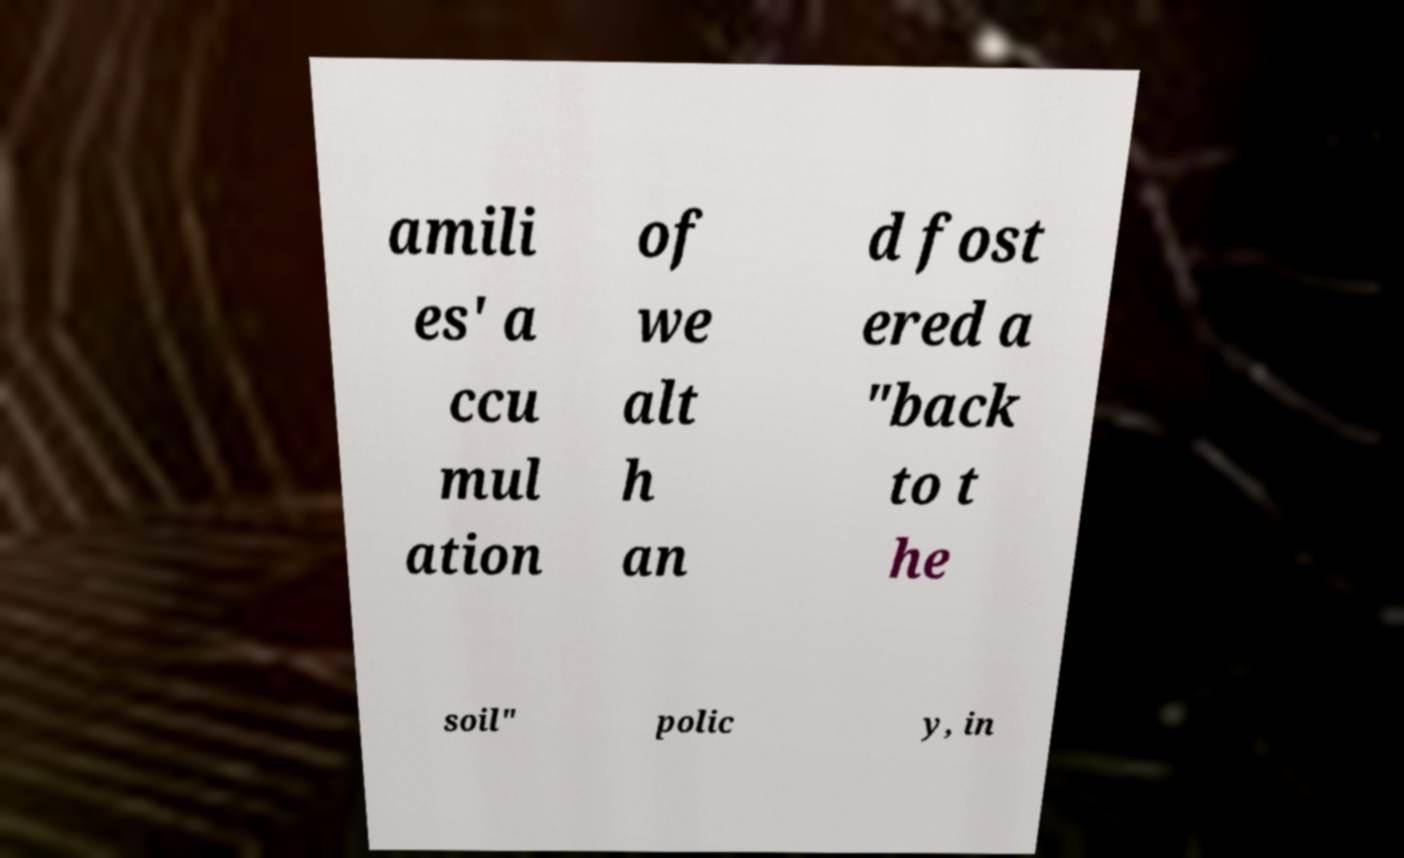For documentation purposes, I need the text within this image transcribed. Could you provide that? amili es' a ccu mul ation of we alt h an d fost ered a "back to t he soil" polic y, in 